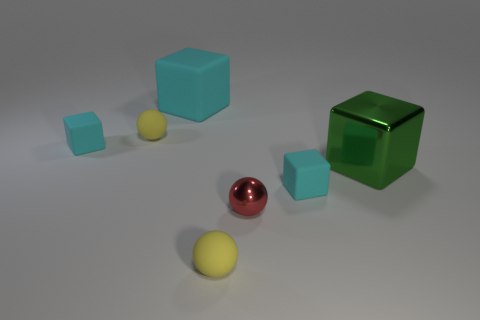Do the small ball that is behind the green object and the rubber sphere on the right side of the large matte cube have the same color?
Give a very brief answer. Yes. What shape is the cyan object that is the same size as the metallic block?
Offer a terse response. Cube. What number of objects are either tiny rubber objects in front of the big green cube or tiny cyan objects behind the green block?
Keep it short and to the point. 3. Is the number of large red rubber cubes less than the number of big rubber cubes?
Your response must be concise. Yes. There is another cube that is the same size as the metallic cube; what is its material?
Keep it short and to the point. Rubber. Does the cyan rubber thing that is left of the large matte thing have the same size as the sphere that is to the left of the large cyan rubber block?
Make the answer very short. Yes. Is there a tiny cyan thing that has the same material as the red ball?
Provide a succinct answer. No. How many things are either small matte things behind the large shiny thing or large matte cubes?
Keep it short and to the point. 3. Are the tiny cyan object in front of the large green metal object and the red sphere made of the same material?
Give a very brief answer. No. Is the big matte thing the same shape as the green object?
Keep it short and to the point. Yes. 